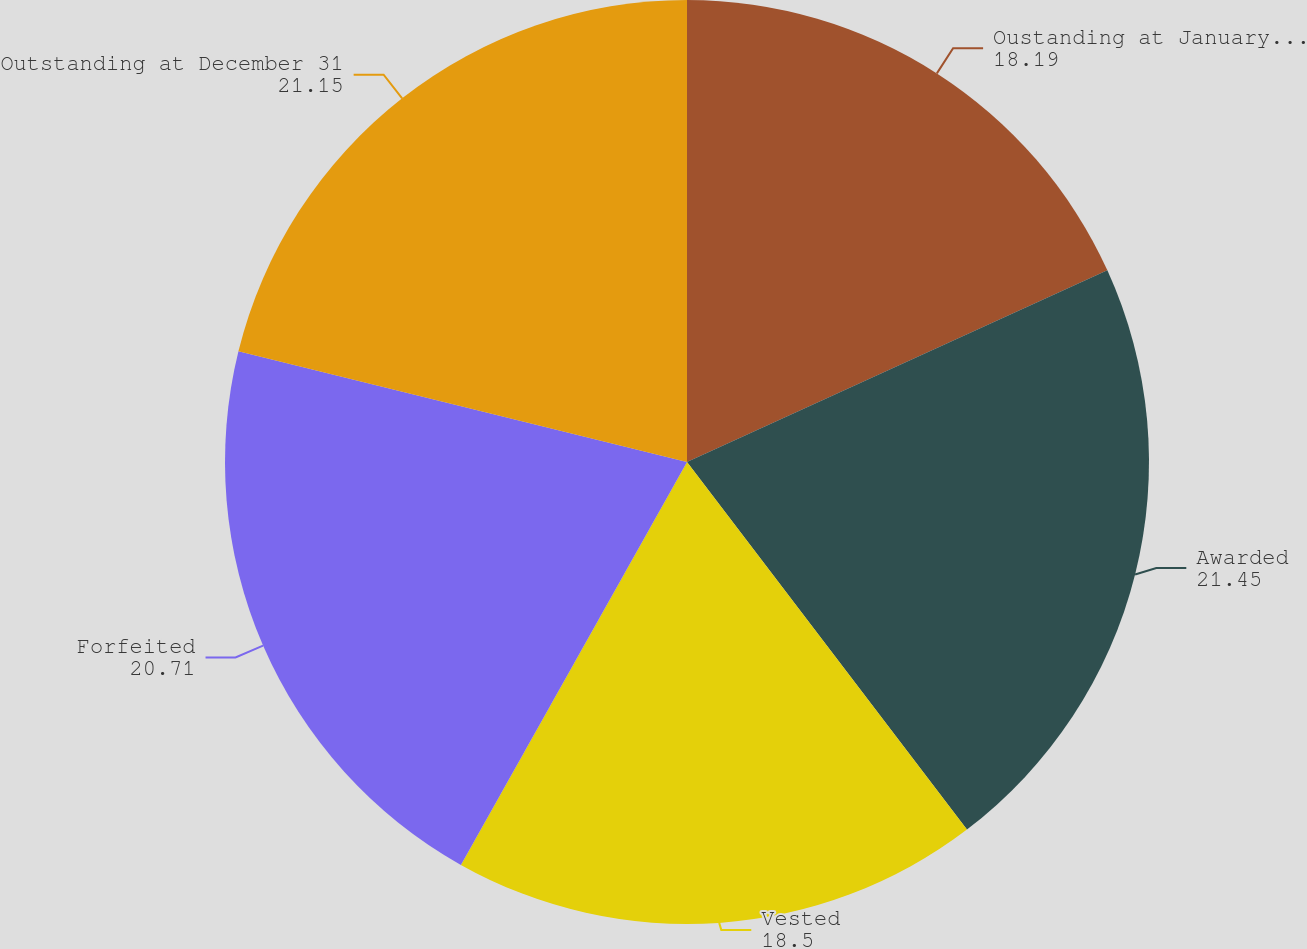<chart> <loc_0><loc_0><loc_500><loc_500><pie_chart><fcel>Oustanding at January 1 2007<fcel>Awarded<fcel>Vested<fcel>Forfeited<fcel>Outstanding at December 31<nl><fcel>18.19%<fcel>21.45%<fcel>18.5%<fcel>20.71%<fcel>21.15%<nl></chart> 